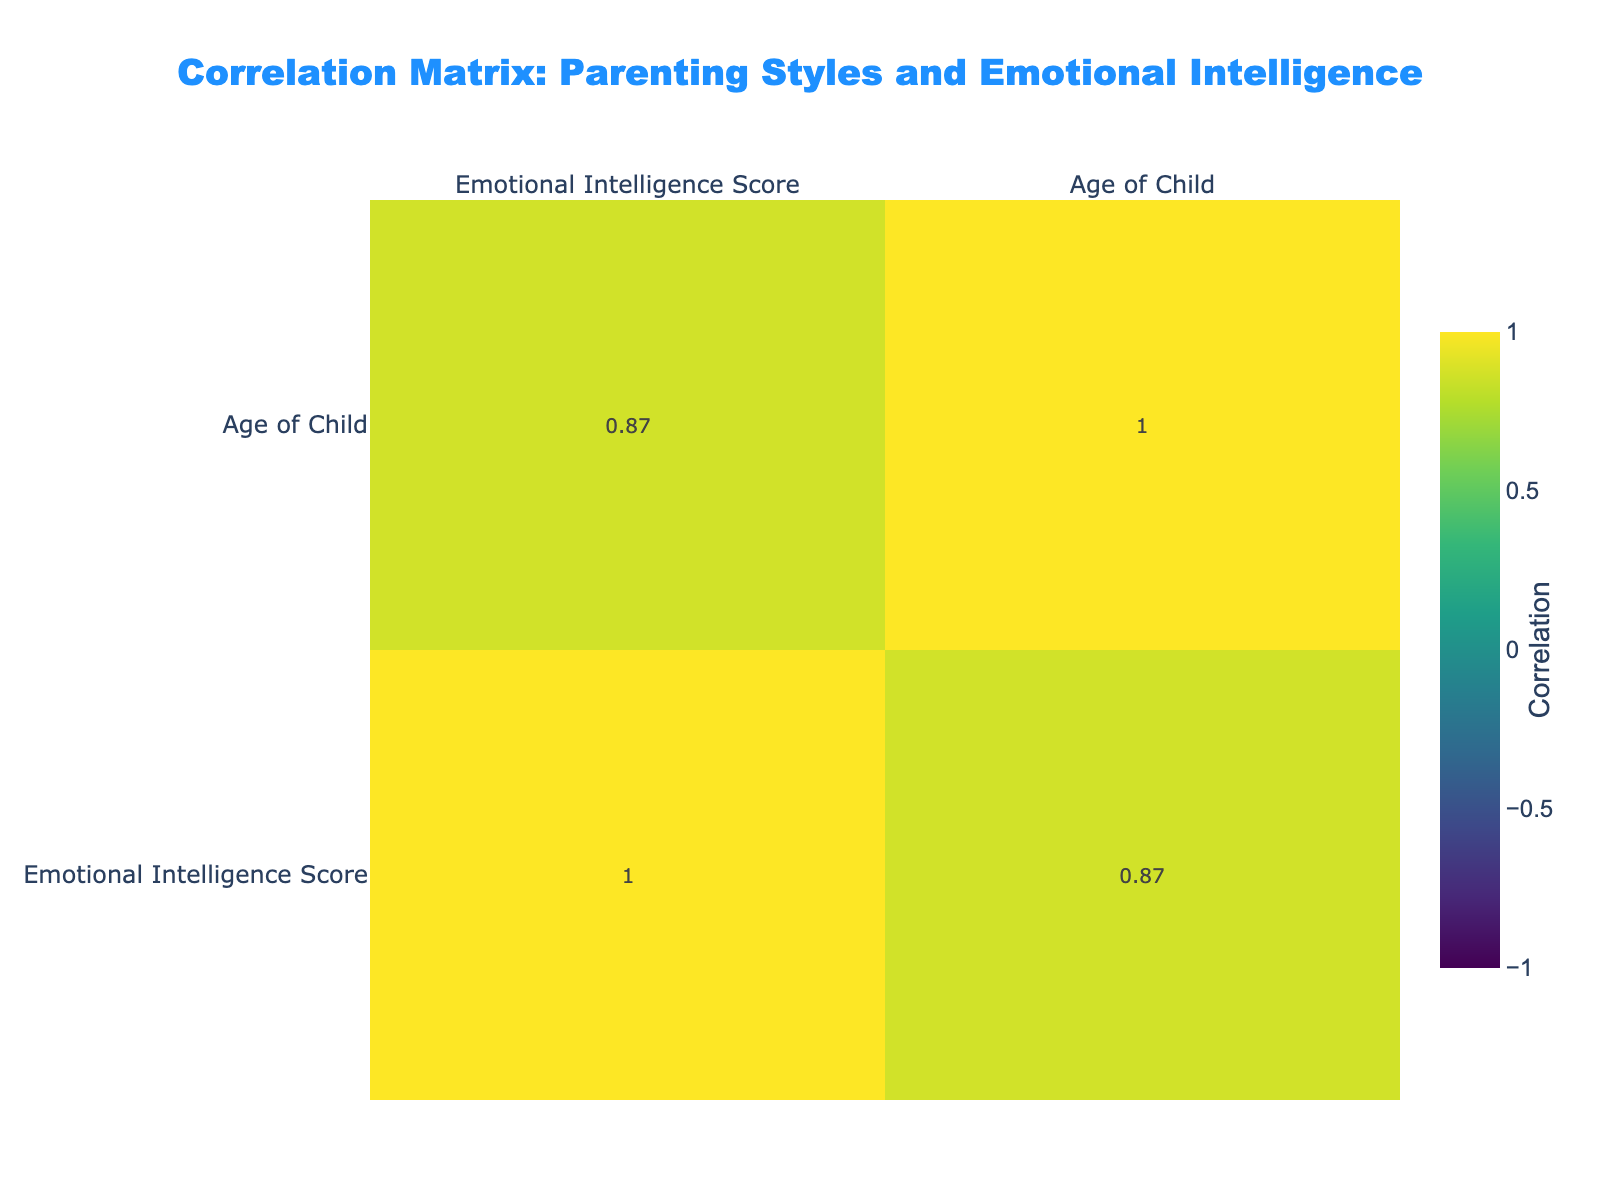What is the Emotional Intelligence Score for the Authoritative parenting style? The table shows three instances of the Authoritative parenting style with scores of 85, 90, and 80. The Emotional Intelligence Score is clearly listed as 85 for the first instance.
Answer: 85 What is the average Emotional Intelligence Score for the Neglectful parenting style? There are three Neglectful parenting records with scores of 55, 50, and 52. To find the average, we add these scores: 55 + 50 + 52 = 157. Then, divide by 3 (the number of records): 157/3 = approx. 52.33.
Answer: 52.33 Is there a Parenting Style that has a Communication Frequency of 'Daily' with a High level of Parental Supportiveness? Reviewing the table, there are multiple parenting styles under "Daily" Communication Frequency. Both instances of the Authoritative style have "Daily" Communication Frequency and "High" Parental Supportiveness confirming a yes.
Answer: Yes Which Parenting Style has the lowest Emotional Intelligence Score? Among all recorded styles, the lowest Emotional Intelligence Score is for the Neglectful style with a score of 50. This can be observed directly from the scores listed in the table.
Answer: Neglectful What is the difference between the highest and lowest Emotional Intelligence Scores among the Permissive parenting style instances? The two recorded scores for Permissive parenting are 78 and 70. To find the difference, subtract the lowest from the highest: 78 - 70 = 8.
Answer: 8 How many instances of Authoritarian parenting style scored less than 60 in Emotional Intelligence? In the table, there are two Authoritarian scores: 65 and 60. However, both values are equal to or greater than 60, leading us to conclude that there are no instances below 60.
Answer: 0 What is the average age of children for Authoritative parenting style? The Authoritative style records involve children aged 8, 10, and 8. To find the average, sum these ages: 8 + 10 + 8 = 26, and divide by 3: 26/3 = approx. 8.67.
Answer: 8.67 Is it true that all parenting styles with High Parental Supportiveness have a Daily Communication Frequency? In the table, both Authoritative instances characterized by High Parental Supportiveness have Daily Communication Frequency, confirming that this pattern holds true for this dataset.
Answer: Yes Which communication frequency is most associated with higher Emotional Intelligence Scores? The table reveals that two of the three highest Emotional Intelligence Scores (85 and 90) are under the Daily communication frequency. This indicates that Daily communication is positively correlated with higher scores.
Answer: Daily 